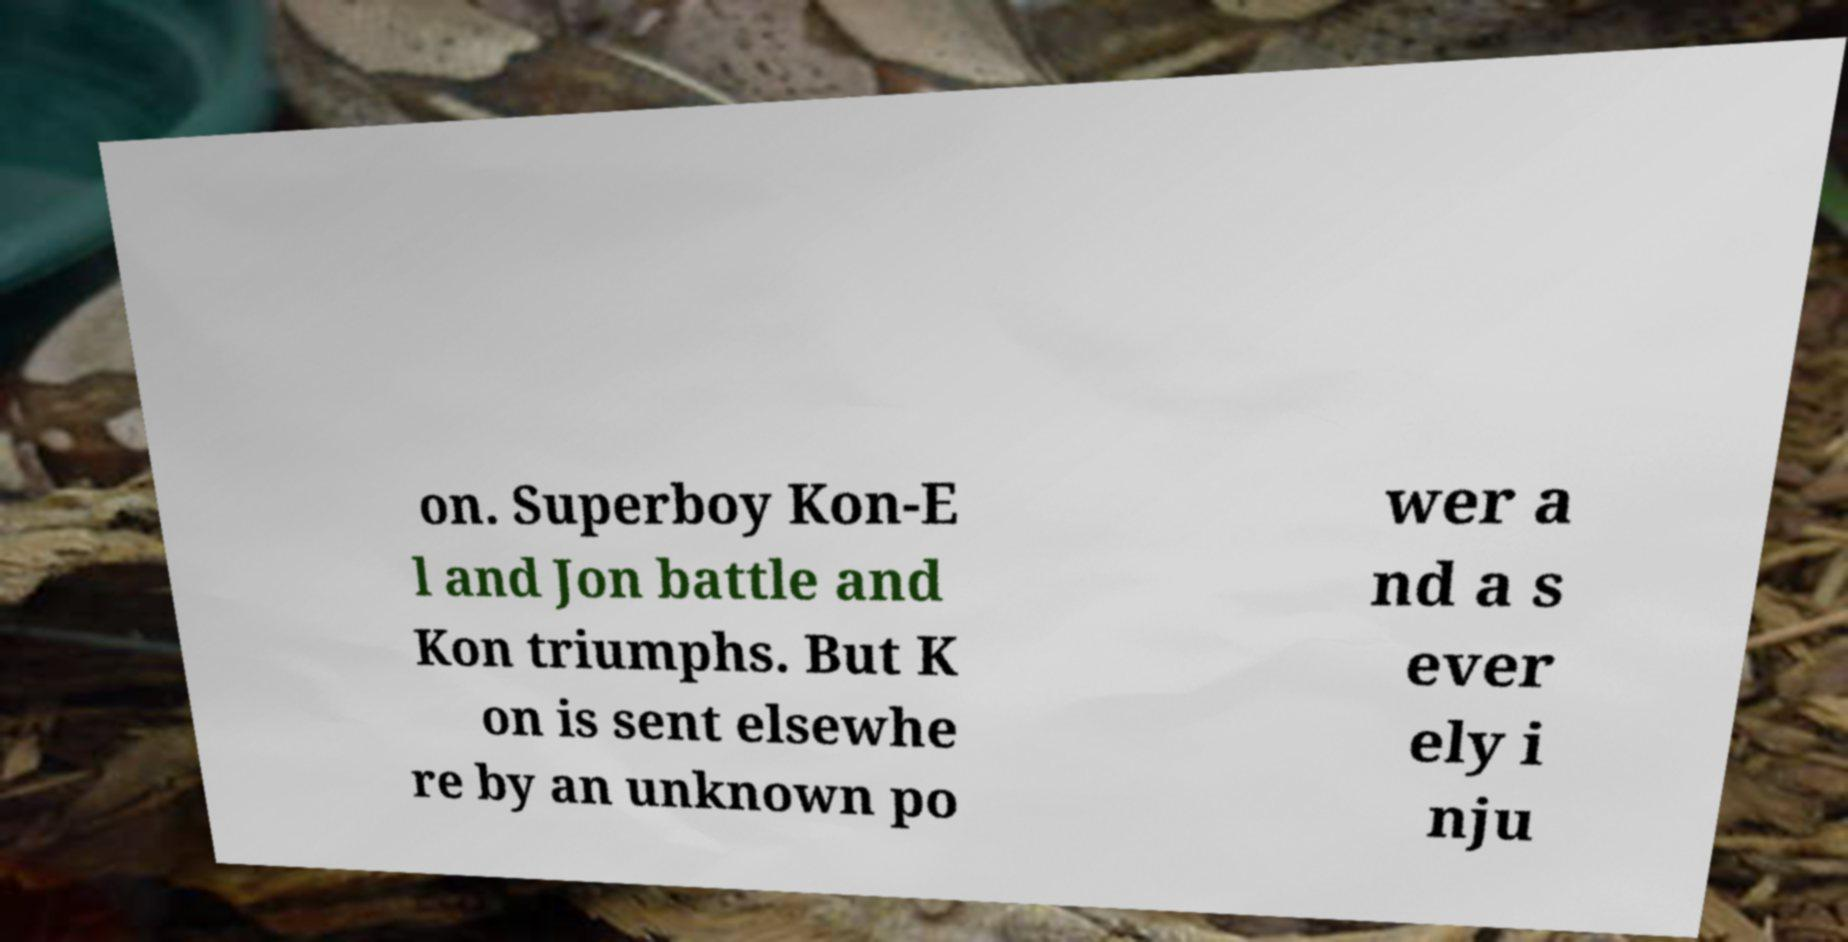What messages or text are displayed in this image? I need them in a readable, typed format. on. Superboy Kon-E l and Jon battle and Kon triumphs. But K on is sent elsewhe re by an unknown po wer a nd a s ever ely i nju 